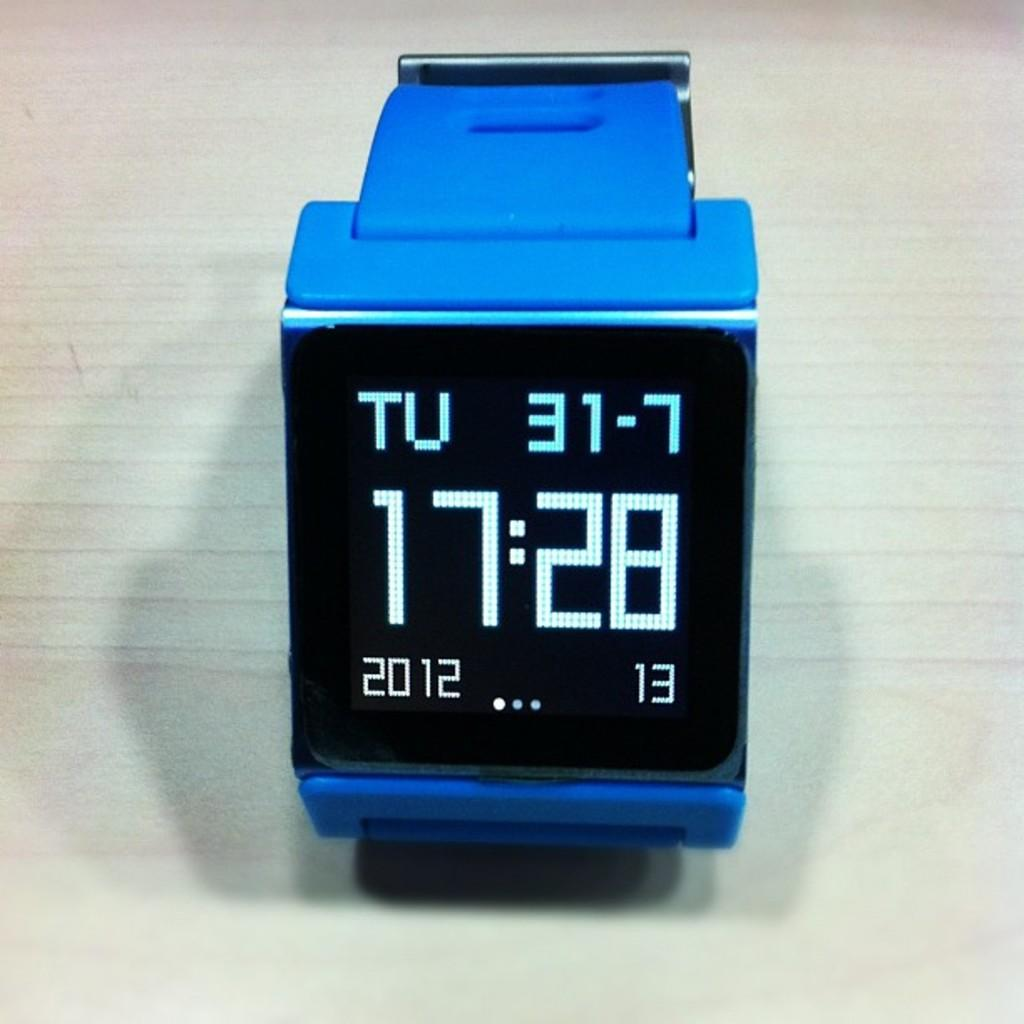<image>
Create a compact narrative representing the image presented. A digital watch with the time 17:28 on its display. 